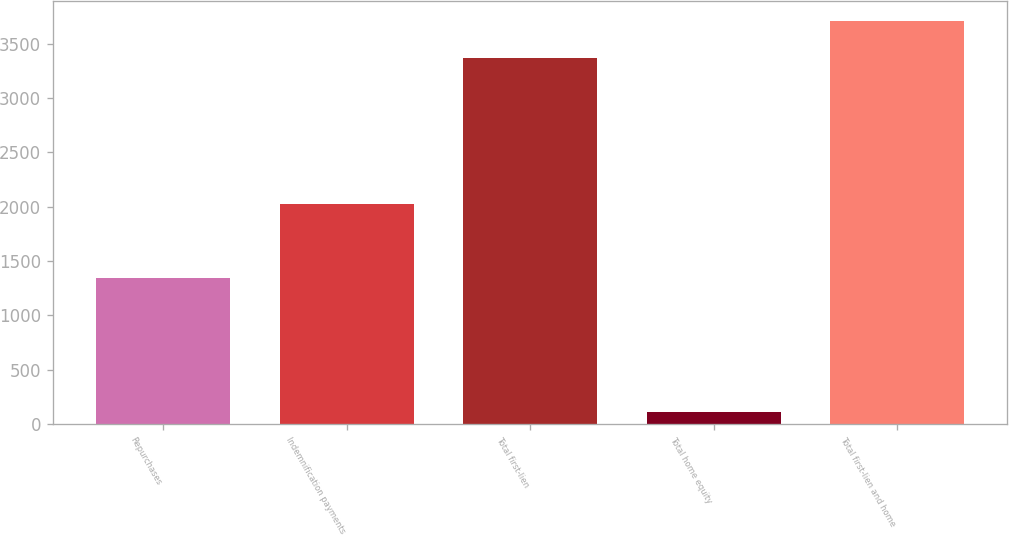Convert chart. <chart><loc_0><loc_0><loc_500><loc_500><bar_chart><fcel>Repurchases<fcel>Indemnification payments<fcel>Total first-lien<fcel>Total home equity<fcel>Total first-lien and home<nl><fcel>1346<fcel>2026<fcel>3372<fcel>113<fcel>3709.2<nl></chart> 